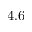Convert formula to latex. <formula><loc_0><loc_0><loc_500><loc_500>4 . 6</formula> 